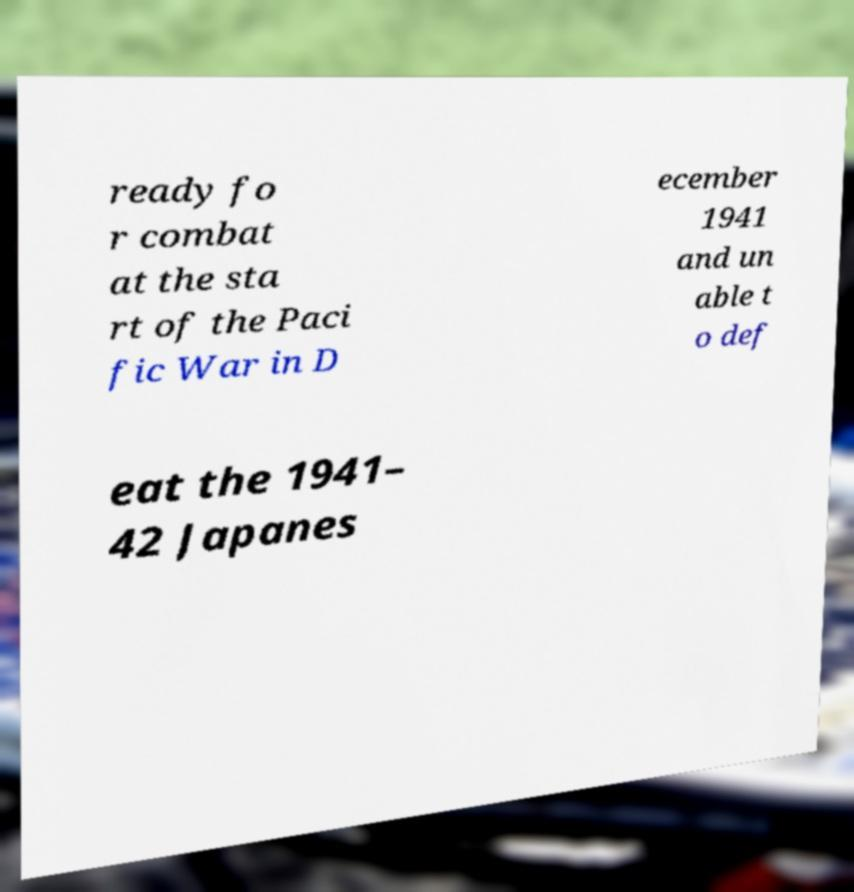Can you accurately transcribe the text from the provided image for me? ready fo r combat at the sta rt of the Paci fic War in D ecember 1941 and un able t o def eat the 1941– 42 Japanes 